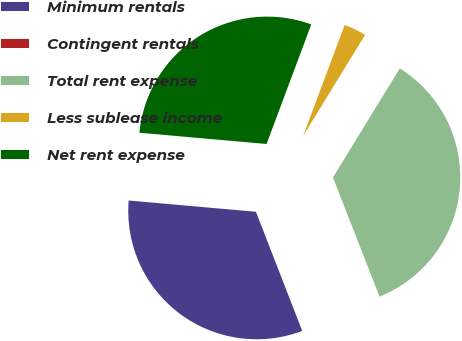<chart> <loc_0><loc_0><loc_500><loc_500><pie_chart><fcel>Minimum rentals<fcel>Contingent rentals<fcel>Total rent expense<fcel>Less sublease income<fcel>Net rent expense<nl><fcel>32.3%<fcel>0.04%<fcel>35.31%<fcel>3.06%<fcel>29.29%<nl></chart> 